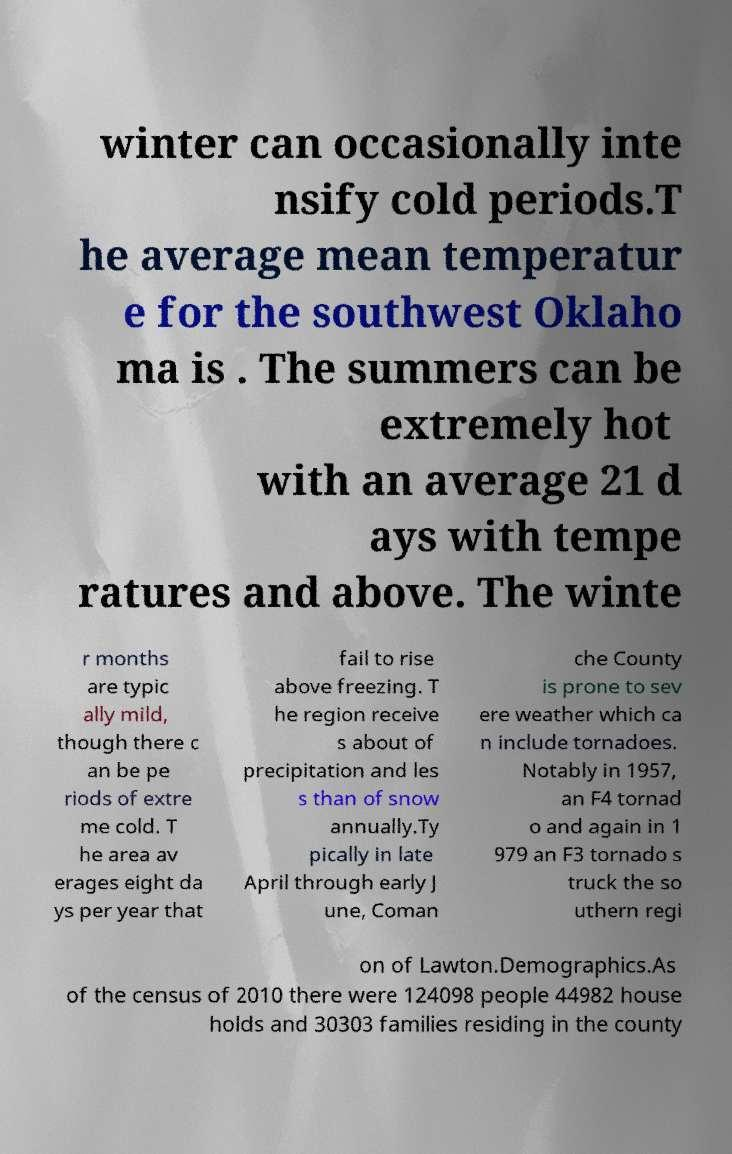I need the written content from this picture converted into text. Can you do that? winter can occasionally inte nsify cold periods.T he average mean temperatur e for the southwest Oklaho ma is . The summers can be extremely hot with an average 21 d ays with tempe ratures and above. The winte r months are typic ally mild, though there c an be pe riods of extre me cold. T he area av erages eight da ys per year that fail to rise above freezing. T he region receive s about of precipitation and les s than of snow annually.Ty pically in late April through early J une, Coman che County is prone to sev ere weather which ca n include tornadoes. Notably in 1957, an F4 tornad o and again in 1 979 an F3 tornado s truck the so uthern regi on of Lawton.Demographics.As of the census of 2010 there were 124098 people 44982 house holds and 30303 families residing in the county 